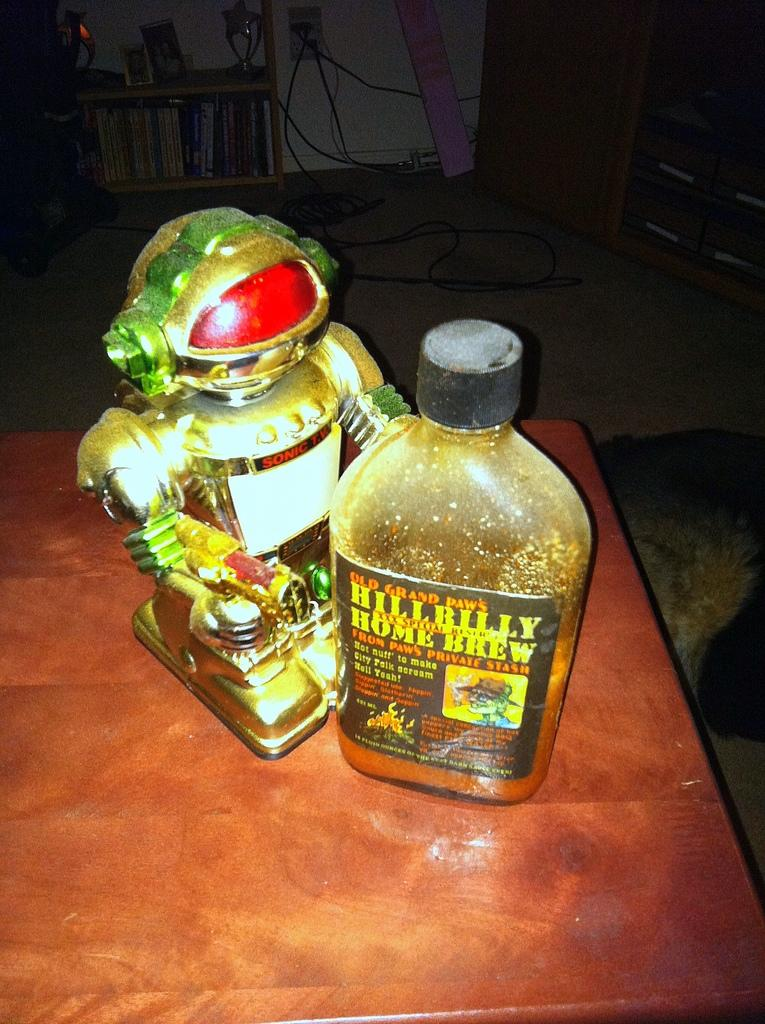<image>
Offer a succinct explanation of the picture presented. A robot is standing next to a bottle of Hillbilly home brew. 